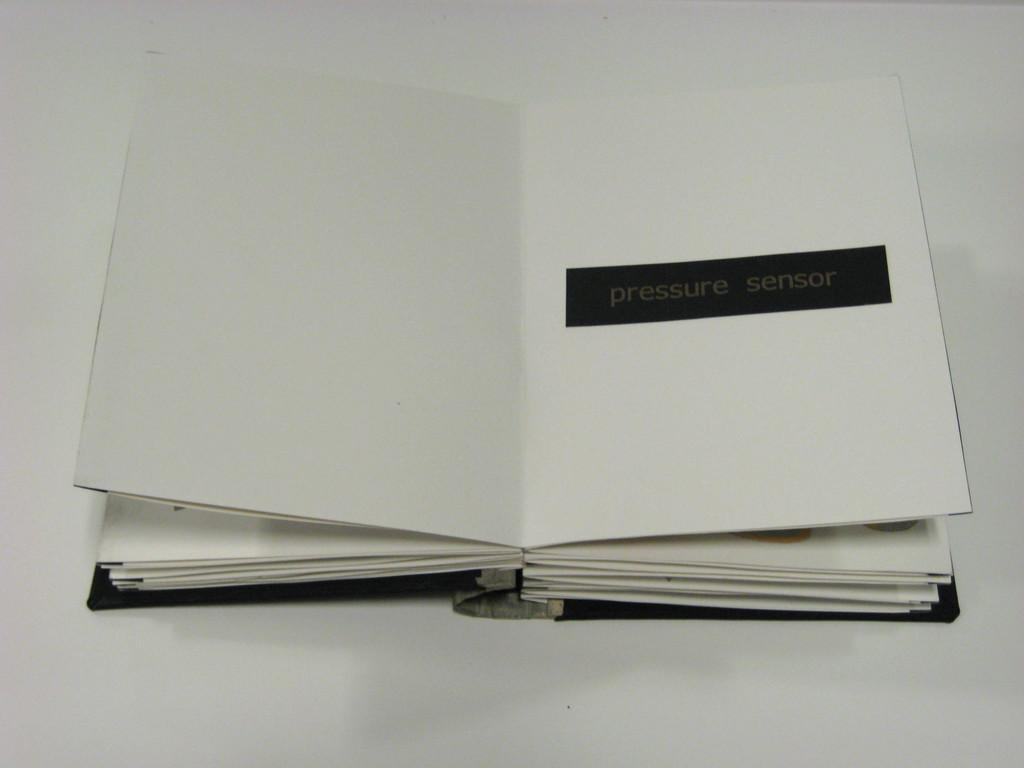<image>
Describe the image concisely. A plain white book is open to a page that says pressure sensor across a black rectangle 